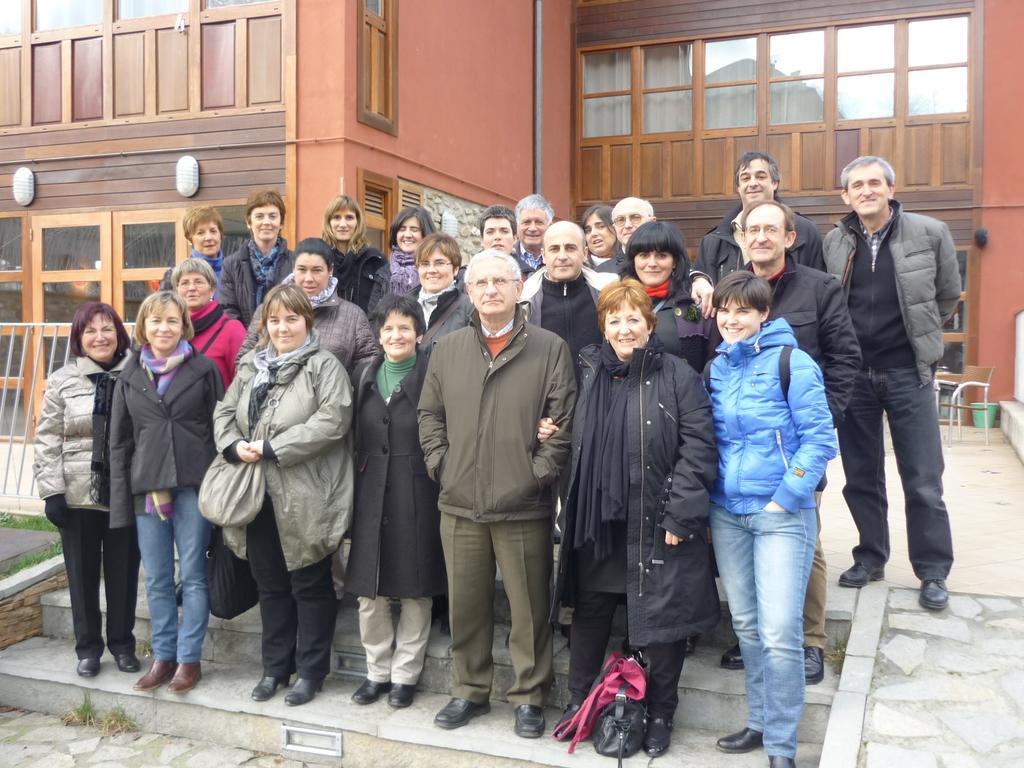Could you give a brief overview of what you see in this image? In this image there is a group of people standing on stairs with a smile on their face, behind them there is a building, in front of the building there is a chair and a trash can. 